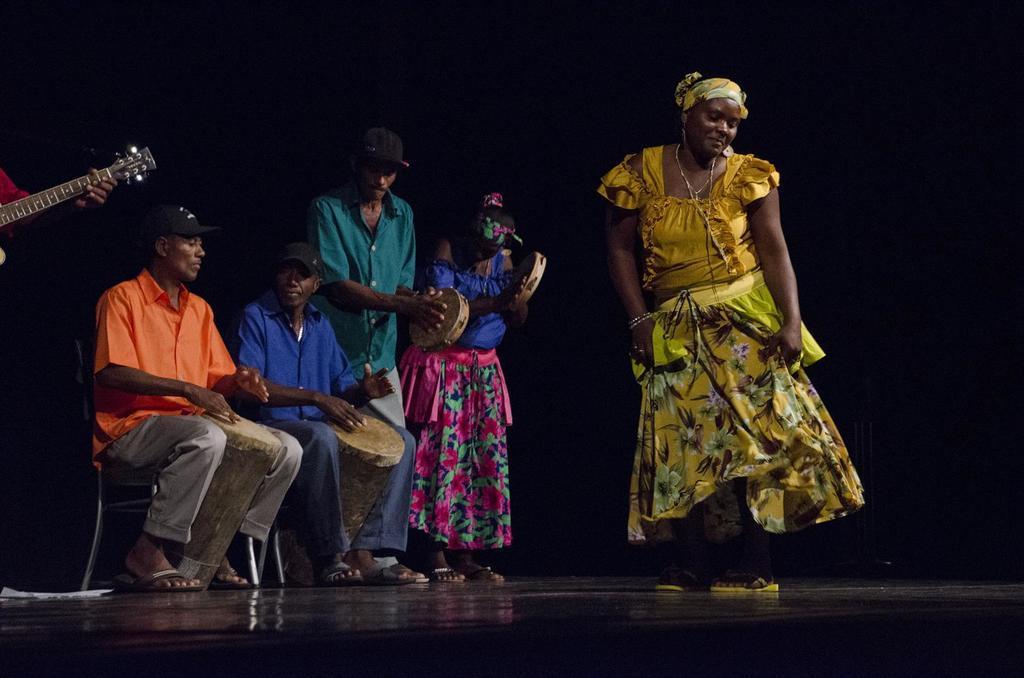Please provide a concise description of this image. The image is clicked during a stage performance. In the center of the picture there is a woman dancing. On the left there are people playing different musical instrument and a person playing guitar. The background is dark. 